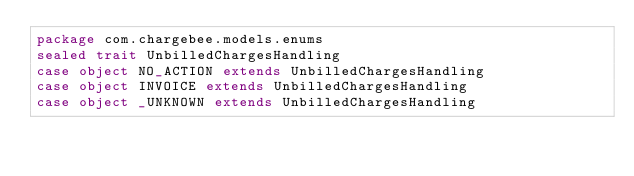Convert code to text. <code><loc_0><loc_0><loc_500><loc_500><_Scala_>package com.chargebee.models.enums 
sealed trait UnbilledChargesHandling 
case object NO_ACTION extends UnbilledChargesHandling 
case object INVOICE extends UnbilledChargesHandling 
case object _UNKNOWN extends UnbilledChargesHandling 
</code> 